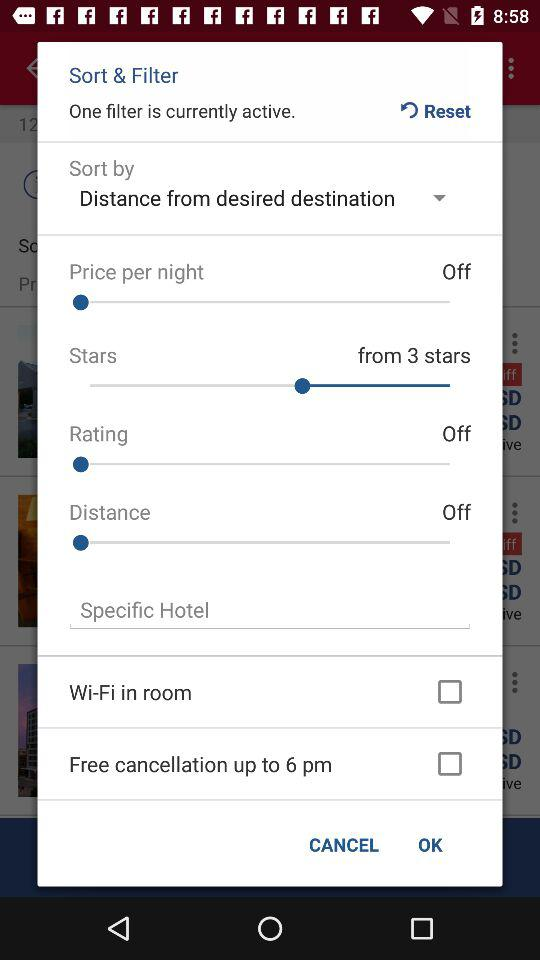Out of how many stars is the star rating chosen? The chosen rating has been provided out of 3 stars. 